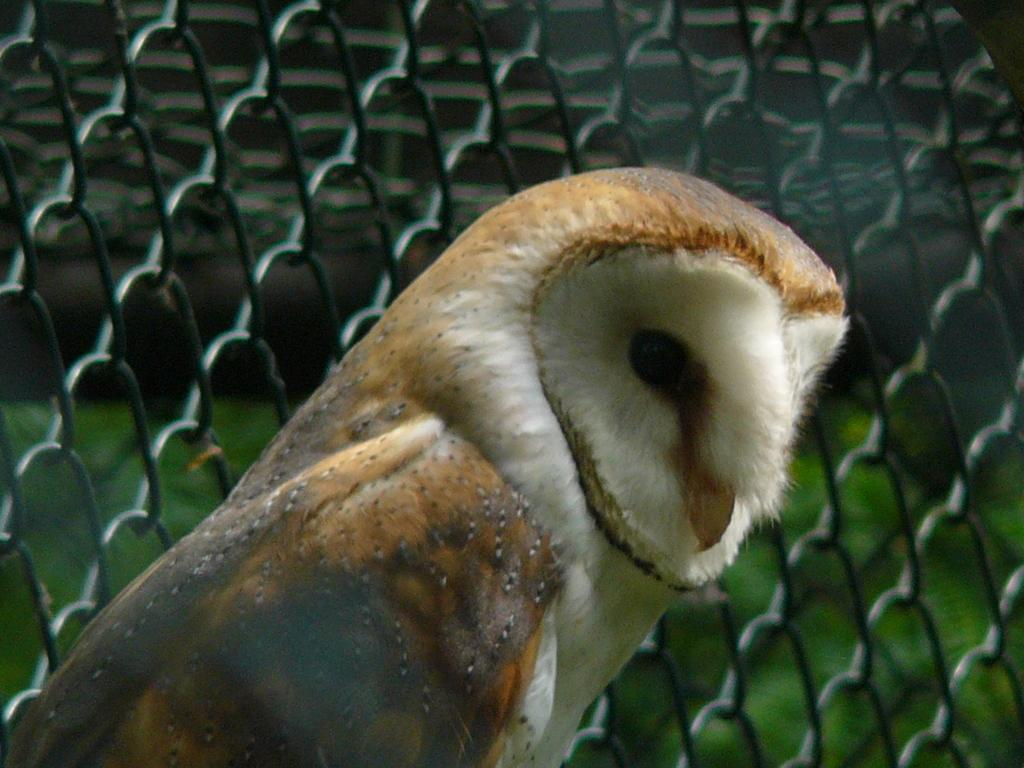What type of animal is in the image? There is a bird in the image. Can you describe the bird's colors? The bird has brown, white, and black colors. What can be seen in the background of the image? The background of the image features net fencing. What type of vegetation is visible in the image? Green grass is visible in the image. What type of root is the bird using to work in the image? There is no root present in the image, and the bird is not shown working. 